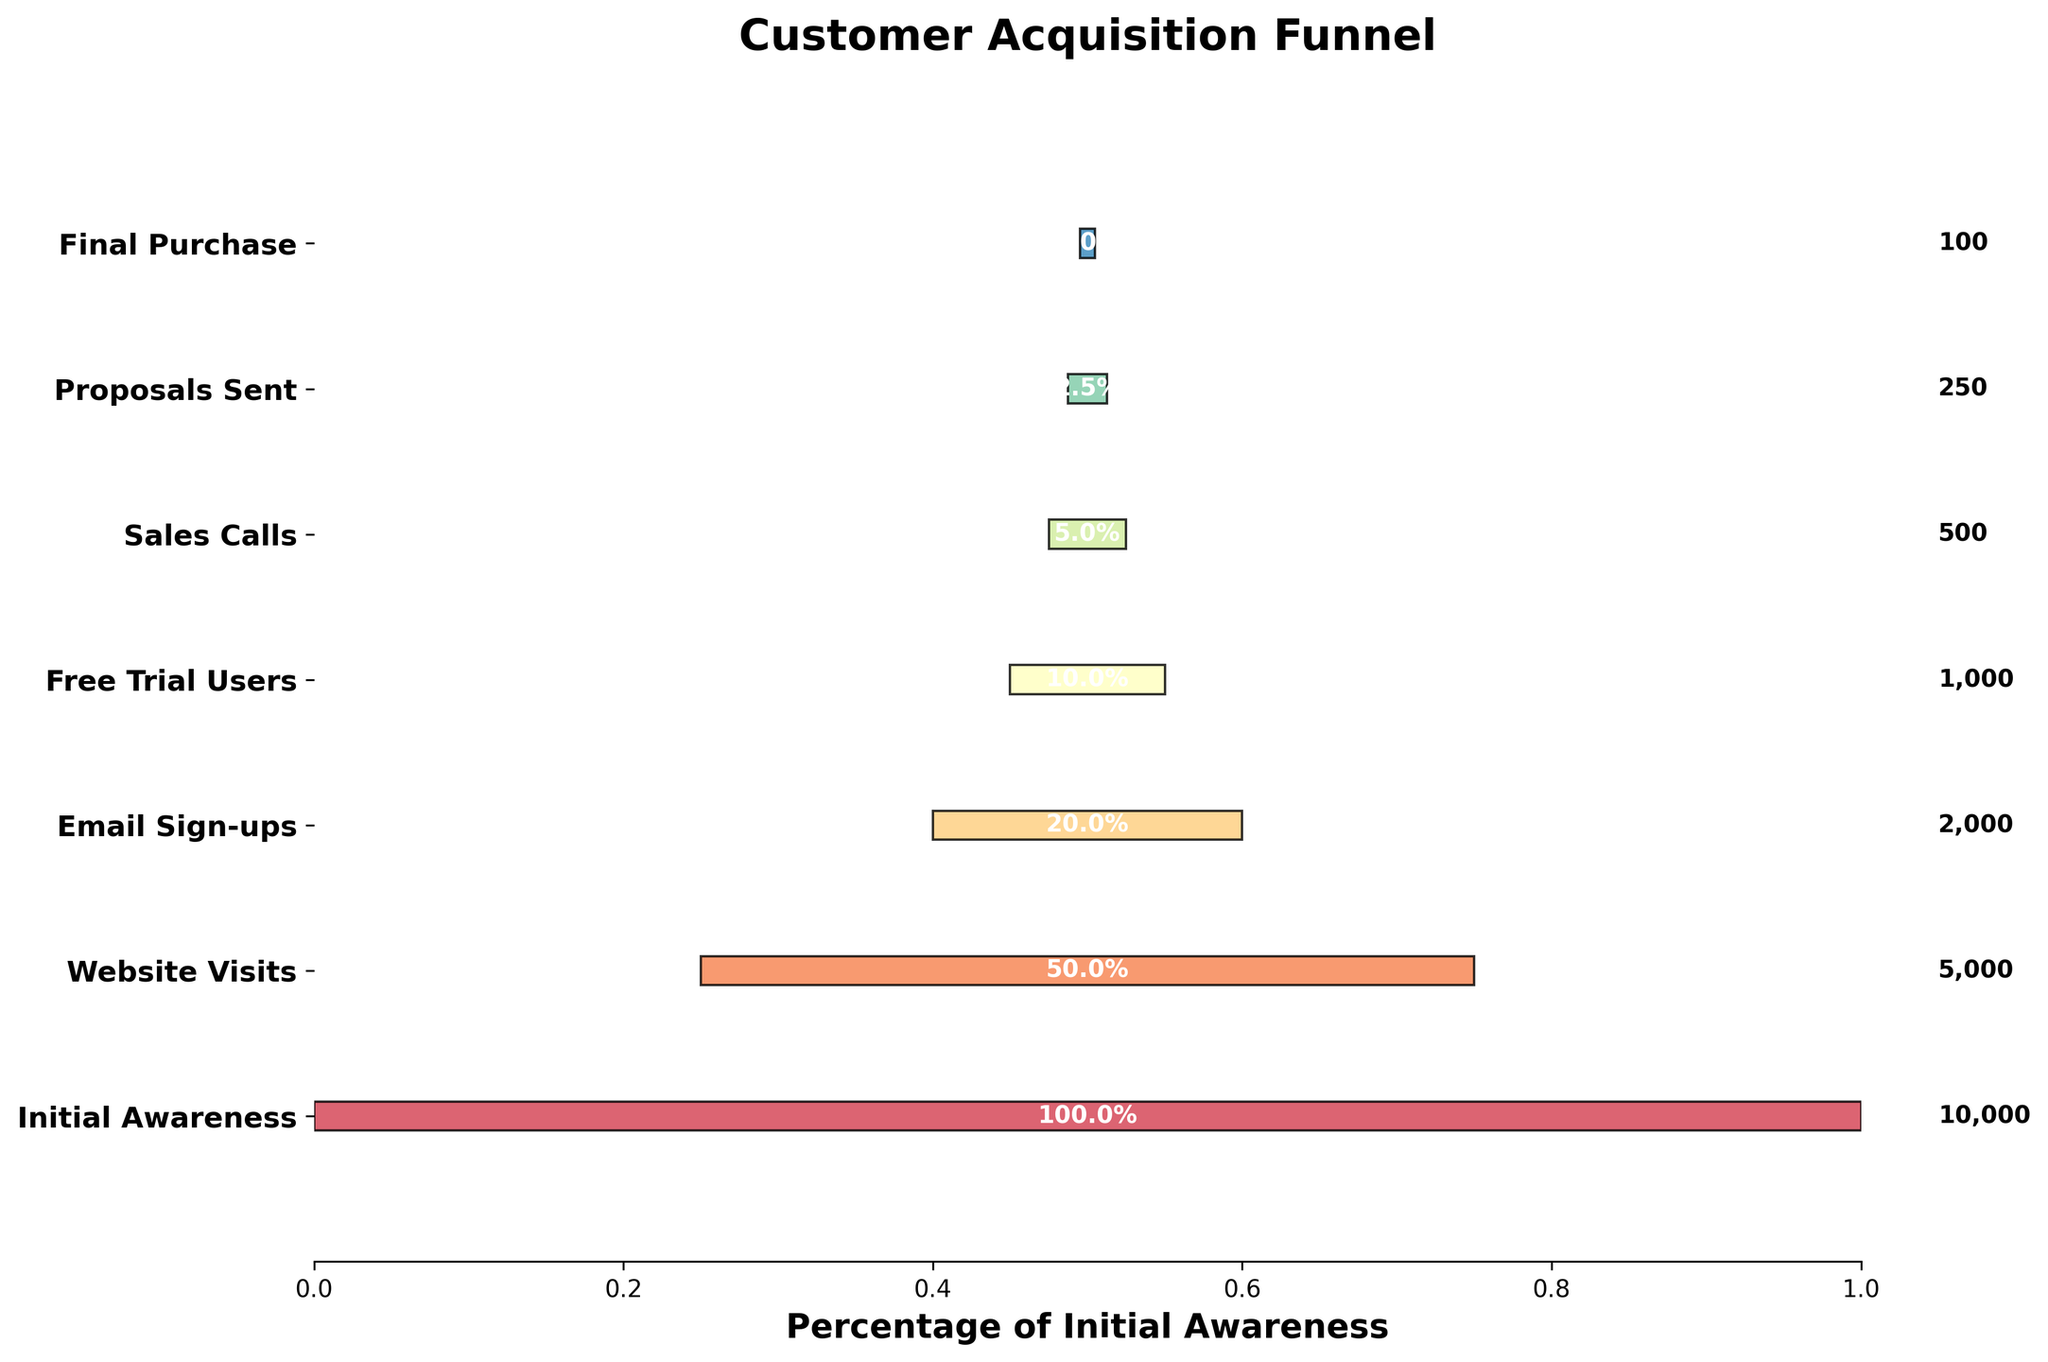What is the title of the chart? The title can be found at the top of the chart. It reads "Customer Acquisition Funnel."
Answer: Customer Acquisition Funnel What is the number of potential customers at the Initial Awareness stage? At the top of the funnel, the chart shows the value labeled "Initial Awareness" stage. The corresponding value is 10,000.
Answer: 10,000 How does the width of the funnel change from Initial Awareness to Final Purchase? The width of the funnel narrows as it progresses from the top (Initial Awareness) stage to the bottom (Final Purchase) stage, indicating a decrease in the number of potential customers at each stage.
Answer: Narrows What percentage of customers who sign up for the free trial end up making the final purchase? From the chart, there are 1,000 Free Trial Users and 100 Final Purchases. To find the percentage: (100 / 1,000) * 100 = 10%.
Answer: 10% Compare the number of potential customers who visit the website versus those who sign up for the email. The chart shows 5,000 Website Visits and 2,000 Email Sign-ups. Website Visits is greater than Email Sign-ups.
Answer: Website Visits > What is the ratio of Proposals Sent to Final Purchases? The chart shows 250 Proposals Sent and 100 Final Purchases. The ratio is calculated as 250:100, which simplifies to 5:2.
Answer: 5:2 By what percentage does the number of potential customers decrease from Sales Calls to Proposals Sent? The chart shows 500 Sales Calls and 250 Proposals Sent. To find the percentage decrease: [(500 - 250) / 500] * 100 = 50%.
Answer: 50% What color represents the Free Trial Users stage in the funnel? The Free Trial Users stage is typically the fourth stage from the top of the funnel, and its color can be identified visually from the chart. The color palette used might be shades from dark to light, approximately reddish.
Answer: Reddish How many stages are there in the customer acquisition funnel? The number of distinct levels in the funnel chart corresponds to the number of stages listed. Counting them gives 7 stages.
Answer: 7 At which stage does the biggest drop-off in potential customers occur? The biggest drop-off can be identified by comparing the differences in consecutive stages' values. The largest difference appears between Initial Awareness (10,000) and Website Visits (5,000) with a drop-off of 5,000.
Answer: Initial Awareness to Website Visits 